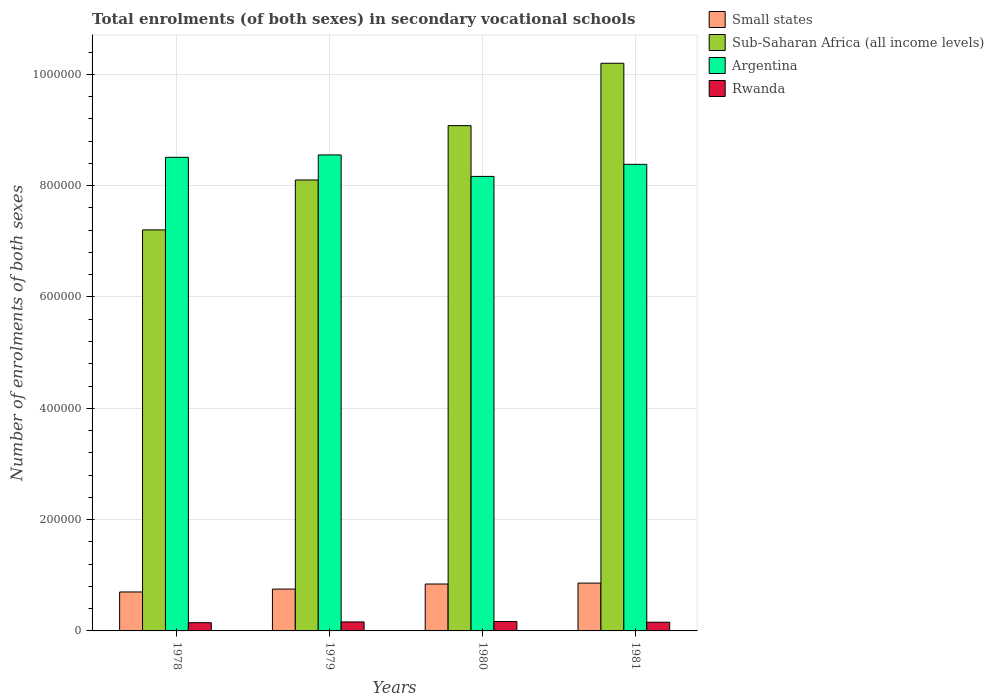Are the number of bars on each tick of the X-axis equal?
Provide a short and direct response. Yes. How many bars are there on the 4th tick from the right?
Your response must be concise. 4. What is the label of the 1st group of bars from the left?
Ensure brevity in your answer.  1978. In how many cases, is the number of bars for a given year not equal to the number of legend labels?
Provide a succinct answer. 0. What is the number of enrolments in secondary schools in Small states in 1979?
Offer a very short reply. 7.52e+04. Across all years, what is the maximum number of enrolments in secondary schools in Argentina?
Provide a short and direct response. 8.55e+05. Across all years, what is the minimum number of enrolments in secondary schools in Argentina?
Your answer should be very brief. 8.17e+05. In which year was the number of enrolments in secondary schools in Sub-Saharan Africa (all income levels) maximum?
Ensure brevity in your answer.  1981. In which year was the number of enrolments in secondary schools in Sub-Saharan Africa (all income levels) minimum?
Offer a terse response. 1978. What is the total number of enrolments in secondary schools in Argentina in the graph?
Offer a very short reply. 3.36e+06. What is the difference between the number of enrolments in secondary schools in Small states in 1978 and that in 1981?
Provide a succinct answer. -1.59e+04. What is the difference between the number of enrolments in secondary schools in Argentina in 1978 and the number of enrolments in secondary schools in Rwanda in 1979?
Your response must be concise. 8.35e+05. What is the average number of enrolments in secondary schools in Argentina per year?
Give a very brief answer. 8.40e+05. In the year 1978, what is the difference between the number of enrolments in secondary schools in Small states and number of enrolments in secondary schools in Rwanda?
Keep it short and to the point. 5.52e+04. What is the ratio of the number of enrolments in secondary schools in Rwanda in 1980 to that in 1981?
Your answer should be very brief. 1.08. Is the number of enrolments in secondary schools in Small states in 1979 less than that in 1981?
Your answer should be very brief. Yes. Is the difference between the number of enrolments in secondary schools in Small states in 1978 and 1980 greater than the difference between the number of enrolments in secondary schools in Rwanda in 1978 and 1980?
Provide a succinct answer. No. What is the difference between the highest and the second highest number of enrolments in secondary schools in Sub-Saharan Africa (all income levels)?
Offer a very short reply. 1.12e+05. What is the difference between the highest and the lowest number of enrolments in secondary schools in Rwanda?
Provide a succinct answer. 2134. In how many years, is the number of enrolments in secondary schools in Small states greater than the average number of enrolments in secondary schools in Small states taken over all years?
Your response must be concise. 2. Is the sum of the number of enrolments in secondary schools in Argentina in 1979 and 1981 greater than the maximum number of enrolments in secondary schools in Rwanda across all years?
Your response must be concise. Yes. Is it the case that in every year, the sum of the number of enrolments in secondary schools in Sub-Saharan Africa (all income levels) and number of enrolments in secondary schools in Rwanda is greater than the sum of number of enrolments in secondary schools in Small states and number of enrolments in secondary schools in Argentina?
Keep it short and to the point. Yes. What does the 4th bar from the right in 1980 represents?
Keep it short and to the point. Small states. How many years are there in the graph?
Provide a short and direct response. 4. Are the values on the major ticks of Y-axis written in scientific E-notation?
Your response must be concise. No. How are the legend labels stacked?
Offer a terse response. Vertical. What is the title of the graph?
Your answer should be very brief. Total enrolments (of both sexes) in secondary vocational schools. Does "Aruba" appear as one of the legend labels in the graph?
Your answer should be very brief. No. What is the label or title of the X-axis?
Ensure brevity in your answer.  Years. What is the label or title of the Y-axis?
Provide a short and direct response. Number of enrolments of both sexes. What is the Number of enrolments of both sexes in Small states in 1978?
Your answer should be compact. 7.00e+04. What is the Number of enrolments of both sexes in Sub-Saharan Africa (all income levels) in 1978?
Offer a very short reply. 7.21e+05. What is the Number of enrolments of both sexes of Argentina in 1978?
Provide a succinct answer. 8.51e+05. What is the Number of enrolments of both sexes of Rwanda in 1978?
Make the answer very short. 1.48e+04. What is the Number of enrolments of both sexes of Small states in 1979?
Make the answer very short. 7.52e+04. What is the Number of enrolments of both sexes in Sub-Saharan Africa (all income levels) in 1979?
Your answer should be compact. 8.10e+05. What is the Number of enrolments of both sexes of Argentina in 1979?
Your answer should be compact. 8.55e+05. What is the Number of enrolments of both sexes in Rwanda in 1979?
Your answer should be very brief. 1.62e+04. What is the Number of enrolments of both sexes in Small states in 1980?
Give a very brief answer. 8.43e+04. What is the Number of enrolments of both sexes of Sub-Saharan Africa (all income levels) in 1980?
Your answer should be very brief. 9.08e+05. What is the Number of enrolments of both sexes in Argentina in 1980?
Keep it short and to the point. 8.17e+05. What is the Number of enrolments of both sexes of Rwanda in 1980?
Give a very brief answer. 1.69e+04. What is the Number of enrolments of both sexes of Small states in 1981?
Give a very brief answer. 8.59e+04. What is the Number of enrolments of both sexes of Sub-Saharan Africa (all income levels) in 1981?
Offer a very short reply. 1.02e+06. What is the Number of enrolments of both sexes of Argentina in 1981?
Provide a short and direct response. 8.38e+05. What is the Number of enrolments of both sexes of Rwanda in 1981?
Your answer should be very brief. 1.56e+04. Across all years, what is the maximum Number of enrolments of both sexes of Small states?
Offer a very short reply. 8.59e+04. Across all years, what is the maximum Number of enrolments of both sexes in Sub-Saharan Africa (all income levels)?
Provide a succinct answer. 1.02e+06. Across all years, what is the maximum Number of enrolments of both sexes in Argentina?
Offer a very short reply. 8.55e+05. Across all years, what is the maximum Number of enrolments of both sexes in Rwanda?
Your answer should be compact. 1.69e+04. Across all years, what is the minimum Number of enrolments of both sexes in Small states?
Offer a terse response. 7.00e+04. Across all years, what is the minimum Number of enrolments of both sexes of Sub-Saharan Africa (all income levels)?
Provide a short and direct response. 7.21e+05. Across all years, what is the minimum Number of enrolments of both sexes of Argentina?
Keep it short and to the point. 8.17e+05. Across all years, what is the minimum Number of enrolments of both sexes in Rwanda?
Give a very brief answer. 1.48e+04. What is the total Number of enrolments of both sexes in Small states in the graph?
Offer a terse response. 3.15e+05. What is the total Number of enrolments of both sexes in Sub-Saharan Africa (all income levels) in the graph?
Provide a succinct answer. 3.46e+06. What is the total Number of enrolments of both sexes in Argentina in the graph?
Keep it short and to the point. 3.36e+06. What is the total Number of enrolments of both sexes in Rwanda in the graph?
Keep it short and to the point. 6.35e+04. What is the difference between the Number of enrolments of both sexes of Small states in 1978 and that in 1979?
Provide a short and direct response. -5160.59. What is the difference between the Number of enrolments of both sexes in Sub-Saharan Africa (all income levels) in 1978 and that in 1979?
Provide a short and direct response. -8.97e+04. What is the difference between the Number of enrolments of both sexes in Argentina in 1978 and that in 1979?
Provide a short and direct response. -4266. What is the difference between the Number of enrolments of both sexes of Rwanda in 1978 and that in 1979?
Make the answer very short. -1369. What is the difference between the Number of enrolments of both sexes of Small states in 1978 and that in 1980?
Your answer should be very brief. -1.43e+04. What is the difference between the Number of enrolments of both sexes in Sub-Saharan Africa (all income levels) in 1978 and that in 1980?
Your answer should be compact. -1.87e+05. What is the difference between the Number of enrolments of both sexes of Argentina in 1978 and that in 1980?
Ensure brevity in your answer.  3.44e+04. What is the difference between the Number of enrolments of both sexes in Rwanda in 1978 and that in 1980?
Offer a terse response. -2134. What is the difference between the Number of enrolments of both sexes in Small states in 1978 and that in 1981?
Your answer should be compact. -1.59e+04. What is the difference between the Number of enrolments of both sexes in Sub-Saharan Africa (all income levels) in 1978 and that in 1981?
Your answer should be compact. -2.99e+05. What is the difference between the Number of enrolments of both sexes of Argentina in 1978 and that in 1981?
Make the answer very short. 1.27e+04. What is the difference between the Number of enrolments of both sexes of Rwanda in 1978 and that in 1981?
Give a very brief answer. -869. What is the difference between the Number of enrolments of both sexes of Small states in 1979 and that in 1980?
Keep it short and to the point. -9110.45. What is the difference between the Number of enrolments of both sexes in Sub-Saharan Africa (all income levels) in 1979 and that in 1980?
Your answer should be compact. -9.76e+04. What is the difference between the Number of enrolments of both sexes in Argentina in 1979 and that in 1980?
Provide a short and direct response. 3.86e+04. What is the difference between the Number of enrolments of both sexes in Rwanda in 1979 and that in 1980?
Give a very brief answer. -765. What is the difference between the Number of enrolments of both sexes of Small states in 1979 and that in 1981?
Ensure brevity in your answer.  -1.08e+04. What is the difference between the Number of enrolments of both sexes in Sub-Saharan Africa (all income levels) in 1979 and that in 1981?
Give a very brief answer. -2.10e+05. What is the difference between the Number of enrolments of both sexes of Argentina in 1979 and that in 1981?
Make the answer very short. 1.69e+04. What is the difference between the Number of enrolments of both sexes in Small states in 1980 and that in 1981?
Your response must be concise. -1655.91. What is the difference between the Number of enrolments of both sexes in Sub-Saharan Africa (all income levels) in 1980 and that in 1981?
Give a very brief answer. -1.12e+05. What is the difference between the Number of enrolments of both sexes in Argentina in 1980 and that in 1981?
Your response must be concise. -2.17e+04. What is the difference between the Number of enrolments of both sexes of Rwanda in 1980 and that in 1981?
Give a very brief answer. 1265. What is the difference between the Number of enrolments of both sexes in Small states in 1978 and the Number of enrolments of both sexes in Sub-Saharan Africa (all income levels) in 1979?
Provide a succinct answer. -7.40e+05. What is the difference between the Number of enrolments of both sexes of Small states in 1978 and the Number of enrolments of both sexes of Argentina in 1979?
Offer a terse response. -7.85e+05. What is the difference between the Number of enrolments of both sexes in Small states in 1978 and the Number of enrolments of both sexes in Rwanda in 1979?
Provide a short and direct response. 5.39e+04. What is the difference between the Number of enrolments of both sexes of Sub-Saharan Africa (all income levels) in 1978 and the Number of enrolments of both sexes of Argentina in 1979?
Offer a terse response. -1.35e+05. What is the difference between the Number of enrolments of both sexes of Sub-Saharan Africa (all income levels) in 1978 and the Number of enrolments of both sexes of Rwanda in 1979?
Your answer should be very brief. 7.04e+05. What is the difference between the Number of enrolments of both sexes of Argentina in 1978 and the Number of enrolments of both sexes of Rwanda in 1979?
Your answer should be compact. 8.35e+05. What is the difference between the Number of enrolments of both sexes in Small states in 1978 and the Number of enrolments of both sexes in Sub-Saharan Africa (all income levels) in 1980?
Give a very brief answer. -8.38e+05. What is the difference between the Number of enrolments of both sexes in Small states in 1978 and the Number of enrolments of both sexes in Argentina in 1980?
Provide a succinct answer. -7.47e+05. What is the difference between the Number of enrolments of both sexes of Small states in 1978 and the Number of enrolments of both sexes of Rwanda in 1980?
Your response must be concise. 5.31e+04. What is the difference between the Number of enrolments of both sexes of Sub-Saharan Africa (all income levels) in 1978 and the Number of enrolments of both sexes of Argentina in 1980?
Offer a terse response. -9.61e+04. What is the difference between the Number of enrolments of both sexes in Sub-Saharan Africa (all income levels) in 1978 and the Number of enrolments of both sexes in Rwanda in 1980?
Offer a very short reply. 7.04e+05. What is the difference between the Number of enrolments of both sexes in Argentina in 1978 and the Number of enrolments of both sexes in Rwanda in 1980?
Make the answer very short. 8.34e+05. What is the difference between the Number of enrolments of both sexes of Small states in 1978 and the Number of enrolments of both sexes of Sub-Saharan Africa (all income levels) in 1981?
Make the answer very short. -9.50e+05. What is the difference between the Number of enrolments of both sexes of Small states in 1978 and the Number of enrolments of both sexes of Argentina in 1981?
Offer a very short reply. -7.68e+05. What is the difference between the Number of enrolments of both sexes in Small states in 1978 and the Number of enrolments of both sexes in Rwanda in 1981?
Offer a very short reply. 5.44e+04. What is the difference between the Number of enrolments of both sexes of Sub-Saharan Africa (all income levels) in 1978 and the Number of enrolments of both sexes of Argentina in 1981?
Your response must be concise. -1.18e+05. What is the difference between the Number of enrolments of both sexes of Sub-Saharan Africa (all income levels) in 1978 and the Number of enrolments of both sexes of Rwanda in 1981?
Give a very brief answer. 7.05e+05. What is the difference between the Number of enrolments of both sexes of Argentina in 1978 and the Number of enrolments of both sexes of Rwanda in 1981?
Your answer should be compact. 8.35e+05. What is the difference between the Number of enrolments of both sexes in Small states in 1979 and the Number of enrolments of both sexes in Sub-Saharan Africa (all income levels) in 1980?
Offer a terse response. -8.33e+05. What is the difference between the Number of enrolments of both sexes of Small states in 1979 and the Number of enrolments of both sexes of Argentina in 1980?
Your answer should be compact. -7.41e+05. What is the difference between the Number of enrolments of both sexes of Small states in 1979 and the Number of enrolments of both sexes of Rwanda in 1980?
Your answer should be very brief. 5.83e+04. What is the difference between the Number of enrolments of both sexes of Sub-Saharan Africa (all income levels) in 1979 and the Number of enrolments of both sexes of Argentina in 1980?
Offer a terse response. -6382.56. What is the difference between the Number of enrolments of both sexes of Sub-Saharan Africa (all income levels) in 1979 and the Number of enrolments of both sexes of Rwanda in 1980?
Give a very brief answer. 7.93e+05. What is the difference between the Number of enrolments of both sexes of Argentina in 1979 and the Number of enrolments of both sexes of Rwanda in 1980?
Give a very brief answer. 8.38e+05. What is the difference between the Number of enrolments of both sexes in Small states in 1979 and the Number of enrolments of both sexes in Sub-Saharan Africa (all income levels) in 1981?
Your response must be concise. -9.45e+05. What is the difference between the Number of enrolments of both sexes of Small states in 1979 and the Number of enrolments of both sexes of Argentina in 1981?
Provide a succinct answer. -7.63e+05. What is the difference between the Number of enrolments of both sexes in Small states in 1979 and the Number of enrolments of both sexes in Rwanda in 1981?
Your answer should be compact. 5.95e+04. What is the difference between the Number of enrolments of both sexes in Sub-Saharan Africa (all income levels) in 1979 and the Number of enrolments of both sexes in Argentina in 1981?
Make the answer very short. -2.81e+04. What is the difference between the Number of enrolments of both sexes in Sub-Saharan Africa (all income levels) in 1979 and the Number of enrolments of both sexes in Rwanda in 1981?
Ensure brevity in your answer.  7.95e+05. What is the difference between the Number of enrolments of both sexes in Argentina in 1979 and the Number of enrolments of both sexes in Rwanda in 1981?
Your answer should be very brief. 8.40e+05. What is the difference between the Number of enrolments of both sexes in Small states in 1980 and the Number of enrolments of both sexes in Sub-Saharan Africa (all income levels) in 1981?
Keep it short and to the point. -9.36e+05. What is the difference between the Number of enrolments of both sexes of Small states in 1980 and the Number of enrolments of both sexes of Argentina in 1981?
Provide a succinct answer. -7.54e+05. What is the difference between the Number of enrolments of both sexes in Small states in 1980 and the Number of enrolments of both sexes in Rwanda in 1981?
Give a very brief answer. 6.86e+04. What is the difference between the Number of enrolments of both sexes of Sub-Saharan Africa (all income levels) in 1980 and the Number of enrolments of both sexes of Argentina in 1981?
Give a very brief answer. 6.95e+04. What is the difference between the Number of enrolments of both sexes in Sub-Saharan Africa (all income levels) in 1980 and the Number of enrolments of both sexes in Rwanda in 1981?
Make the answer very short. 8.92e+05. What is the difference between the Number of enrolments of both sexes of Argentina in 1980 and the Number of enrolments of both sexes of Rwanda in 1981?
Give a very brief answer. 8.01e+05. What is the average Number of enrolments of both sexes in Small states per year?
Provide a short and direct response. 7.88e+04. What is the average Number of enrolments of both sexes of Sub-Saharan Africa (all income levels) per year?
Provide a short and direct response. 8.65e+05. What is the average Number of enrolments of both sexes in Argentina per year?
Offer a very short reply. 8.40e+05. What is the average Number of enrolments of both sexes of Rwanda per year?
Make the answer very short. 1.59e+04. In the year 1978, what is the difference between the Number of enrolments of both sexes of Small states and Number of enrolments of both sexes of Sub-Saharan Africa (all income levels)?
Offer a very short reply. -6.51e+05. In the year 1978, what is the difference between the Number of enrolments of both sexes of Small states and Number of enrolments of both sexes of Argentina?
Your answer should be compact. -7.81e+05. In the year 1978, what is the difference between the Number of enrolments of both sexes of Small states and Number of enrolments of both sexes of Rwanda?
Give a very brief answer. 5.52e+04. In the year 1978, what is the difference between the Number of enrolments of both sexes of Sub-Saharan Africa (all income levels) and Number of enrolments of both sexes of Argentina?
Provide a succinct answer. -1.30e+05. In the year 1978, what is the difference between the Number of enrolments of both sexes in Sub-Saharan Africa (all income levels) and Number of enrolments of both sexes in Rwanda?
Offer a terse response. 7.06e+05. In the year 1978, what is the difference between the Number of enrolments of both sexes in Argentina and Number of enrolments of both sexes in Rwanda?
Give a very brief answer. 8.36e+05. In the year 1979, what is the difference between the Number of enrolments of both sexes of Small states and Number of enrolments of both sexes of Sub-Saharan Africa (all income levels)?
Give a very brief answer. -7.35e+05. In the year 1979, what is the difference between the Number of enrolments of both sexes of Small states and Number of enrolments of both sexes of Argentina?
Provide a succinct answer. -7.80e+05. In the year 1979, what is the difference between the Number of enrolments of both sexes in Small states and Number of enrolments of both sexes in Rwanda?
Offer a very short reply. 5.90e+04. In the year 1979, what is the difference between the Number of enrolments of both sexes of Sub-Saharan Africa (all income levels) and Number of enrolments of both sexes of Argentina?
Provide a short and direct response. -4.50e+04. In the year 1979, what is the difference between the Number of enrolments of both sexes of Sub-Saharan Africa (all income levels) and Number of enrolments of both sexes of Rwanda?
Provide a short and direct response. 7.94e+05. In the year 1979, what is the difference between the Number of enrolments of both sexes in Argentina and Number of enrolments of both sexes in Rwanda?
Offer a terse response. 8.39e+05. In the year 1980, what is the difference between the Number of enrolments of both sexes of Small states and Number of enrolments of both sexes of Sub-Saharan Africa (all income levels)?
Make the answer very short. -8.24e+05. In the year 1980, what is the difference between the Number of enrolments of both sexes in Small states and Number of enrolments of both sexes in Argentina?
Give a very brief answer. -7.32e+05. In the year 1980, what is the difference between the Number of enrolments of both sexes in Small states and Number of enrolments of both sexes in Rwanda?
Give a very brief answer. 6.74e+04. In the year 1980, what is the difference between the Number of enrolments of both sexes in Sub-Saharan Africa (all income levels) and Number of enrolments of both sexes in Argentina?
Your answer should be very brief. 9.12e+04. In the year 1980, what is the difference between the Number of enrolments of both sexes in Sub-Saharan Africa (all income levels) and Number of enrolments of both sexes in Rwanda?
Your response must be concise. 8.91e+05. In the year 1980, what is the difference between the Number of enrolments of both sexes in Argentina and Number of enrolments of both sexes in Rwanda?
Keep it short and to the point. 8.00e+05. In the year 1981, what is the difference between the Number of enrolments of both sexes in Small states and Number of enrolments of both sexes in Sub-Saharan Africa (all income levels)?
Give a very brief answer. -9.34e+05. In the year 1981, what is the difference between the Number of enrolments of both sexes of Small states and Number of enrolments of both sexes of Argentina?
Offer a very short reply. -7.52e+05. In the year 1981, what is the difference between the Number of enrolments of both sexes of Small states and Number of enrolments of both sexes of Rwanda?
Keep it short and to the point. 7.03e+04. In the year 1981, what is the difference between the Number of enrolments of both sexes in Sub-Saharan Africa (all income levels) and Number of enrolments of both sexes in Argentina?
Your answer should be compact. 1.82e+05. In the year 1981, what is the difference between the Number of enrolments of both sexes of Sub-Saharan Africa (all income levels) and Number of enrolments of both sexes of Rwanda?
Make the answer very short. 1.00e+06. In the year 1981, what is the difference between the Number of enrolments of both sexes in Argentina and Number of enrolments of both sexes in Rwanda?
Give a very brief answer. 8.23e+05. What is the ratio of the Number of enrolments of both sexes in Small states in 1978 to that in 1979?
Keep it short and to the point. 0.93. What is the ratio of the Number of enrolments of both sexes in Sub-Saharan Africa (all income levels) in 1978 to that in 1979?
Ensure brevity in your answer.  0.89. What is the ratio of the Number of enrolments of both sexes in Argentina in 1978 to that in 1979?
Your response must be concise. 0.99. What is the ratio of the Number of enrolments of both sexes in Rwanda in 1978 to that in 1979?
Ensure brevity in your answer.  0.92. What is the ratio of the Number of enrolments of both sexes in Small states in 1978 to that in 1980?
Keep it short and to the point. 0.83. What is the ratio of the Number of enrolments of both sexes in Sub-Saharan Africa (all income levels) in 1978 to that in 1980?
Offer a very short reply. 0.79. What is the ratio of the Number of enrolments of both sexes of Argentina in 1978 to that in 1980?
Offer a very short reply. 1.04. What is the ratio of the Number of enrolments of both sexes in Rwanda in 1978 to that in 1980?
Provide a short and direct response. 0.87. What is the ratio of the Number of enrolments of both sexes of Small states in 1978 to that in 1981?
Ensure brevity in your answer.  0.81. What is the ratio of the Number of enrolments of both sexes in Sub-Saharan Africa (all income levels) in 1978 to that in 1981?
Provide a short and direct response. 0.71. What is the ratio of the Number of enrolments of both sexes of Argentina in 1978 to that in 1981?
Ensure brevity in your answer.  1.02. What is the ratio of the Number of enrolments of both sexes in Rwanda in 1978 to that in 1981?
Offer a very short reply. 0.94. What is the ratio of the Number of enrolments of both sexes of Small states in 1979 to that in 1980?
Provide a succinct answer. 0.89. What is the ratio of the Number of enrolments of both sexes in Sub-Saharan Africa (all income levels) in 1979 to that in 1980?
Your answer should be compact. 0.89. What is the ratio of the Number of enrolments of both sexes of Argentina in 1979 to that in 1980?
Your response must be concise. 1.05. What is the ratio of the Number of enrolments of both sexes in Rwanda in 1979 to that in 1980?
Your answer should be very brief. 0.95. What is the ratio of the Number of enrolments of both sexes of Small states in 1979 to that in 1981?
Your response must be concise. 0.87. What is the ratio of the Number of enrolments of both sexes in Sub-Saharan Africa (all income levels) in 1979 to that in 1981?
Your answer should be very brief. 0.79. What is the ratio of the Number of enrolments of both sexes of Argentina in 1979 to that in 1981?
Keep it short and to the point. 1.02. What is the ratio of the Number of enrolments of both sexes of Rwanda in 1979 to that in 1981?
Give a very brief answer. 1.03. What is the ratio of the Number of enrolments of both sexes in Small states in 1980 to that in 1981?
Give a very brief answer. 0.98. What is the ratio of the Number of enrolments of both sexes in Sub-Saharan Africa (all income levels) in 1980 to that in 1981?
Give a very brief answer. 0.89. What is the ratio of the Number of enrolments of both sexes of Argentina in 1980 to that in 1981?
Offer a very short reply. 0.97. What is the ratio of the Number of enrolments of both sexes in Rwanda in 1980 to that in 1981?
Provide a succinct answer. 1.08. What is the difference between the highest and the second highest Number of enrolments of both sexes in Small states?
Give a very brief answer. 1655.91. What is the difference between the highest and the second highest Number of enrolments of both sexes of Sub-Saharan Africa (all income levels)?
Make the answer very short. 1.12e+05. What is the difference between the highest and the second highest Number of enrolments of both sexes of Argentina?
Your answer should be very brief. 4266. What is the difference between the highest and the second highest Number of enrolments of both sexes of Rwanda?
Ensure brevity in your answer.  765. What is the difference between the highest and the lowest Number of enrolments of both sexes of Small states?
Your answer should be very brief. 1.59e+04. What is the difference between the highest and the lowest Number of enrolments of both sexes in Sub-Saharan Africa (all income levels)?
Ensure brevity in your answer.  2.99e+05. What is the difference between the highest and the lowest Number of enrolments of both sexes of Argentina?
Provide a short and direct response. 3.86e+04. What is the difference between the highest and the lowest Number of enrolments of both sexes in Rwanda?
Your answer should be very brief. 2134. 